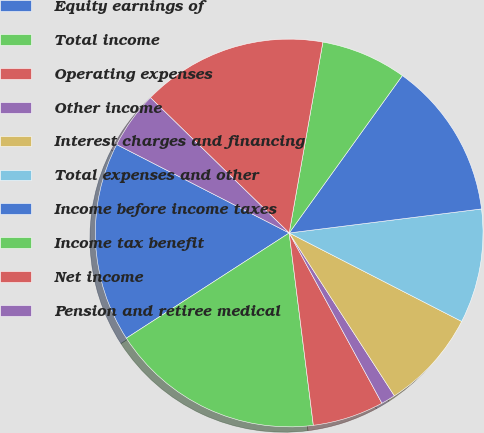Convert chart. <chart><loc_0><loc_0><loc_500><loc_500><pie_chart><fcel>Equity earnings of<fcel>Total income<fcel>Operating expenses<fcel>Other income<fcel>Interest charges and financing<fcel>Total expenses and other<fcel>Income before income taxes<fcel>Income tax benefit<fcel>Net income<fcel>Pension and retiree medical<nl><fcel>16.67%<fcel>17.86%<fcel>5.95%<fcel>1.19%<fcel>8.33%<fcel>9.52%<fcel>13.1%<fcel>7.14%<fcel>15.48%<fcel>4.76%<nl></chart> 